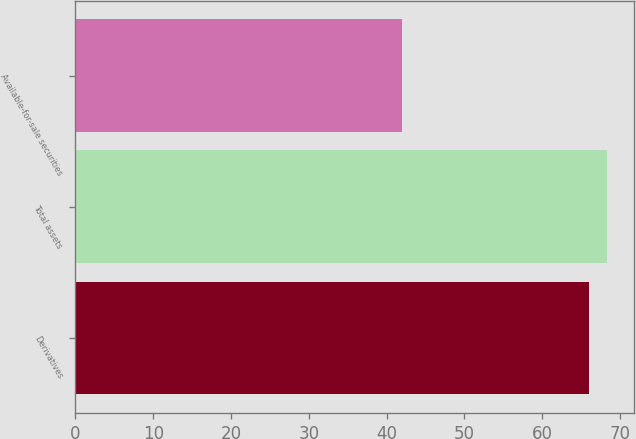Convert chart. <chart><loc_0><loc_0><loc_500><loc_500><bar_chart><fcel>Derivatives<fcel>Total assets<fcel>Available-for-sale securities<nl><fcel>66<fcel>68.4<fcel>42<nl></chart> 